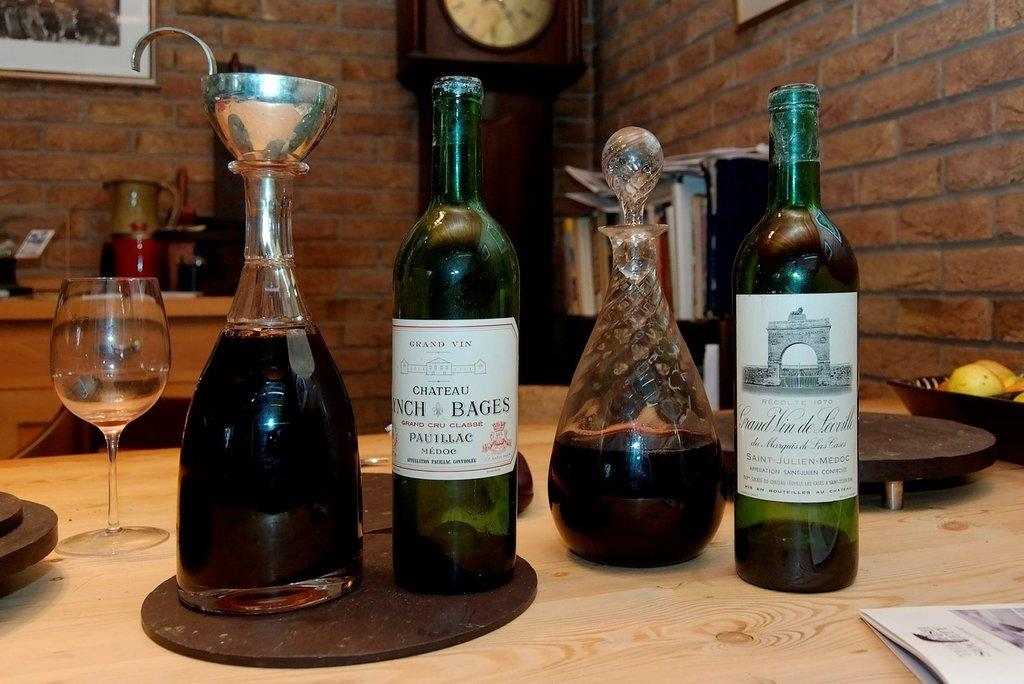What type of beverage containers are in the image? There are wine bottles in the image. What is the glassware item in the image? There is a wine glass in the image. On which side of the image is the wine glass located? The wine glass is on the left side. What time-telling device is present in the image? There is a wall clock in the image. What type of wall is visible in the image? There is a brick wall in the image. What direction is the north in the image? There is no reference to direction, such as north, in the image. 